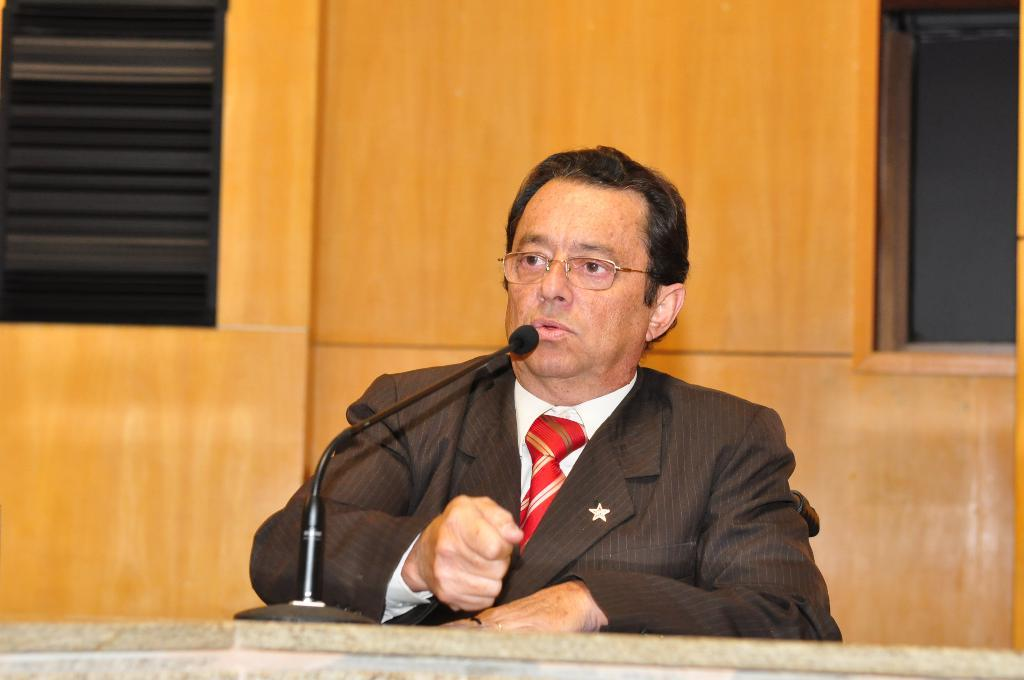Who is the main subject in the image? There is a man in the image. What is the man doing in the image? The man is talking in the image. What is the man using to amplify his voice? There is a microphone in front of the man. What can be seen in the background of the image? There is a wall in the background of the image. What architectural feature is present on the right side of the image? There is a window on the right side of the image. How many bulbs are visible in the image? There are no bulbs visible in the image. What type of frogs can be seen in the image? There are no frogs present in the image. 